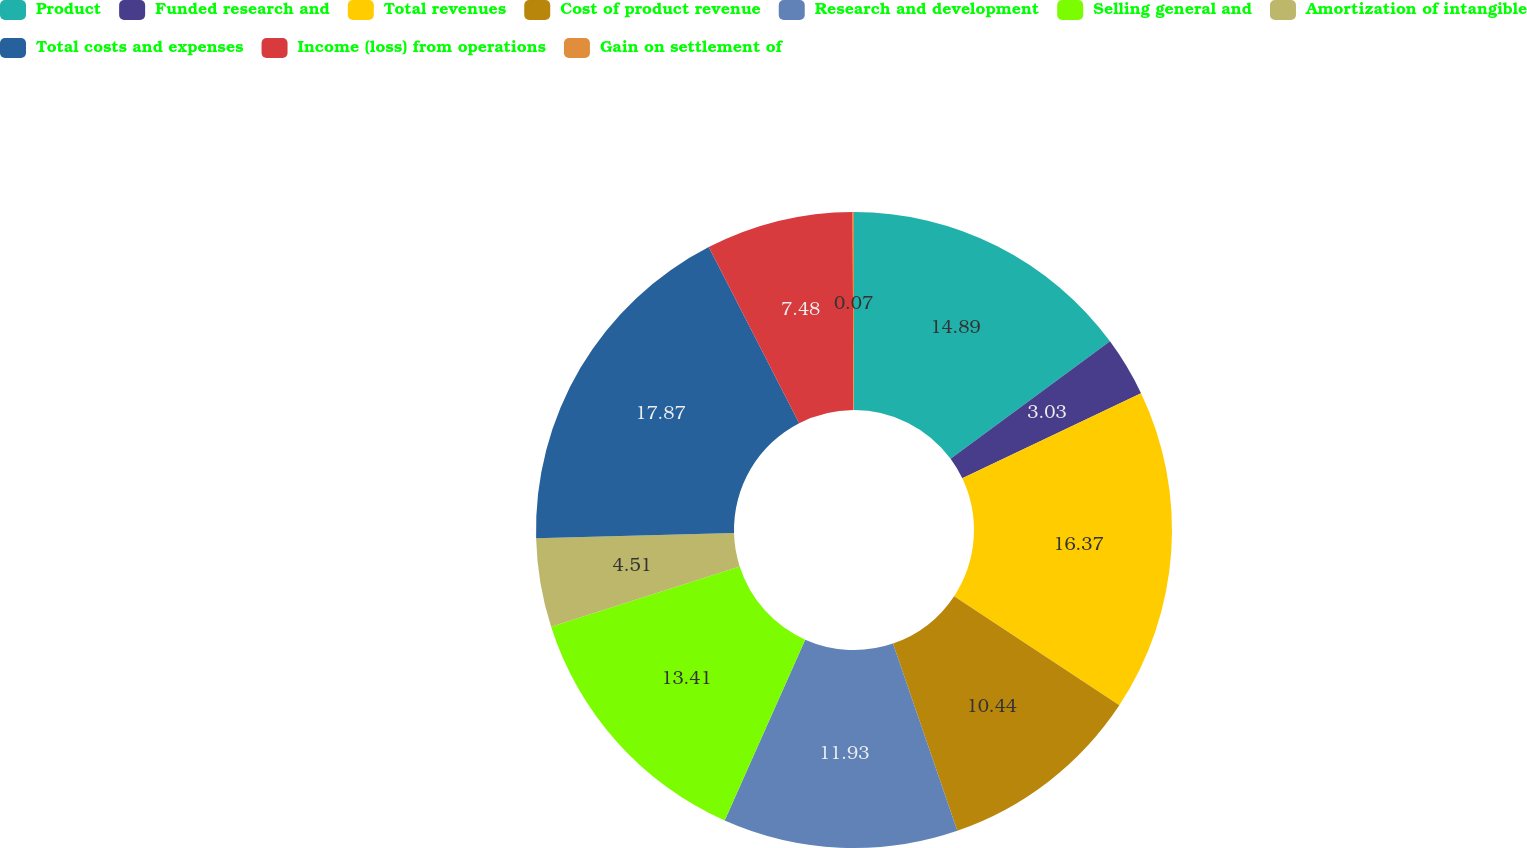<chart> <loc_0><loc_0><loc_500><loc_500><pie_chart><fcel>Product<fcel>Funded research and<fcel>Total revenues<fcel>Cost of product revenue<fcel>Research and development<fcel>Selling general and<fcel>Amortization of intangible<fcel>Total costs and expenses<fcel>Income (loss) from operations<fcel>Gain on settlement of<nl><fcel>14.89%<fcel>3.03%<fcel>16.37%<fcel>10.44%<fcel>11.93%<fcel>13.41%<fcel>4.51%<fcel>17.86%<fcel>7.48%<fcel>0.07%<nl></chart> 